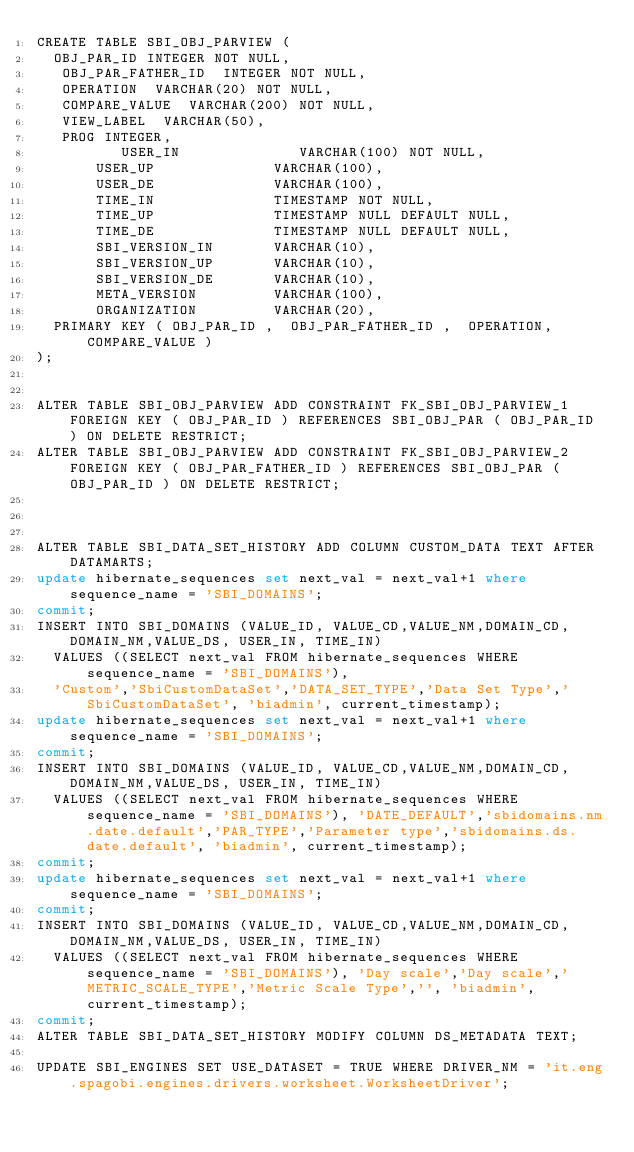Convert code to text. <code><loc_0><loc_0><loc_500><loc_500><_SQL_>CREATE TABLE SBI_OBJ_PARVIEW (
  OBJ_PAR_ID INTEGER NOT NULL,
   OBJ_PAR_FATHER_ID  INTEGER NOT NULL,
   OPERATION  VARCHAR(20) NOT NULL,
   COMPARE_VALUE  VARCHAR(200) NOT NULL,
   VIEW_LABEL  VARCHAR(50),
   PROG INTEGER,
          USER_IN              VARCHAR(100) NOT NULL,
       USER_UP              VARCHAR(100),
       USER_DE              VARCHAR(100),
       TIME_IN              TIMESTAMP NOT NULL,
       TIME_UP              TIMESTAMP NULL DEFAULT NULL,
       TIME_DE              TIMESTAMP NULL DEFAULT NULL,
       SBI_VERSION_IN       VARCHAR(10),
       SBI_VERSION_UP       VARCHAR(10),
       SBI_VERSION_DE       VARCHAR(10),
       META_VERSION         VARCHAR(100),
       ORGANIZATION         VARCHAR(20),    
  PRIMARY KEY ( OBJ_PAR_ID ,  OBJ_PAR_FATHER_ID ,  OPERATION, COMPARE_VALUE )
);


ALTER TABLE SBI_OBJ_PARVIEW ADD CONSTRAINT FK_SBI_OBJ_PARVIEW_1 FOREIGN KEY ( OBJ_PAR_ID ) REFERENCES SBI_OBJ_PAR ( OBJ_PAR_ID ) ON DELETE RESTRICT;
ALTER TABLE SBI_OBJ_PARVIEW ADD CONSTRAINT FK_SBI_OBJ_PARVIEW_2 FOREIGN KEY ( OBJ_PAR_FATHER_ID ) REFERENCES SBI_OBJ_PAR ( OBJ_PAR_ID ) ON DELETE RESTRICT;



ALTER TABLE SBI_DATA_SET_HISTORY ADD COLUMN CUSTOM_DATA TEXT AFTER DATAMARTS;
update hibernate_sequences set next_val = next_val+1 where  sequence_name = 'SBI_DOMAINS';
commit;
INSERT INTO SBI_DOMAINS (VALUE_ID, VALUE_CD,VALUE_NM,DOMAIN_CD,DOMAIN_NM,VALUE_DS, USER_IN, TIME_IN)
	VALUES ((SELECT next_val FROM hibernate_sequences WHERE sequence_name = 'SBI_DOMAINS'),
	'Custom','SbiCustomDataSet','DATA_SET_TYPE','Data Set Type','SbiCustomDataSet', 'biadmin', current_timestamp);
update hibernate_sequences set next_val = next_val+1 where  sequence_name = 'SBI_DOMAINS';
commit;
INSERT INTO SBI_DOMAINS (VALUE_ID, VALUE_CD,VALUE_NM,DOMAIN_CD,DOMAIN_NM,VALUE_DS, USER_IN, TIME_IN)
	VALUES ((SELECT next_val FROM hibernate_sequences WHERE sequence_name = 'SBI_DOMAINS'),	'DATE_DEFAULT','sbidomains.nm.date.default','PAR_TYPE','Parameter type','sbidomains.ds.date.default', 'biadmin', current_timestamp);
commit;
update hibernate_sequences set next_val = next_val+1 where  sequence_name = 'SBI_DOMAINS';
commit;
INSERT INTO SBI_DOMAINS (VALUE_ID, VALUE_CD,VALUE_NM,DOMAIN_CD,DOMAIN_NM,VALUE_DS, USER_IN, TIME_IN)
	VALUES ((SELECT next_val FROM hibernate_sequences WHERE sequence_name = 'SBI_DOMAINS'),	'Day scale','Day scale','METRIC_SCALE_TYPE','Metric Scale Type','', 'biadmin', current_timestamp);
commit;	
ALTER TABLE SBI_DATA_SET_HISTORY MODIFY COLUMN DS_METADATA TEXT;

UPDATE SBI_ENGINES SET USE_DATASET = TRUE WHERE DRIVER_NM = 'it.eng.spagobi.engines.drivers.worksheet.WorksheetDriver';</code> 